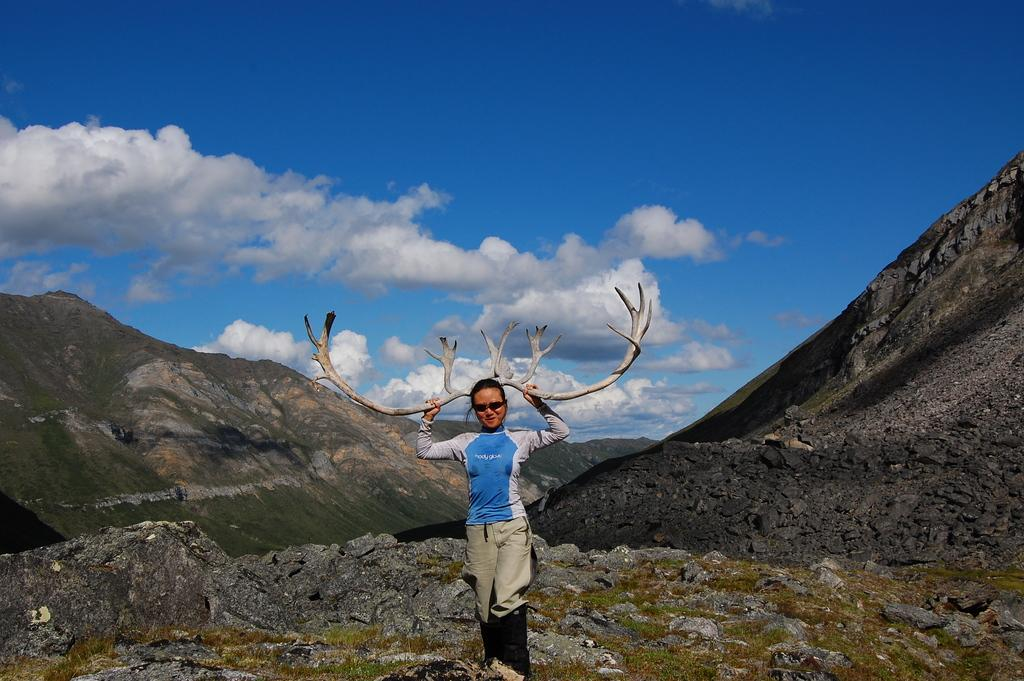What can be seen in the sky in the image? Clouds are visible in the image. What type of natural feature is present in the image? There are mountains in the image. What is the woman holding in the image? The woman is holding an object. What is the woman wearing on her head in the image? The woman is wearing a hood. What is the woman standing on in the image? There is a rock in the image. What type of structure can be seen in the image? There is no structure present in the image; it features a sky, clouds, mountains, a rock, and a woman. How many fingers can be seen on the woman's hand in the image? The image does not show the woman's hand or fingers, so it cannot be determined from the image. 